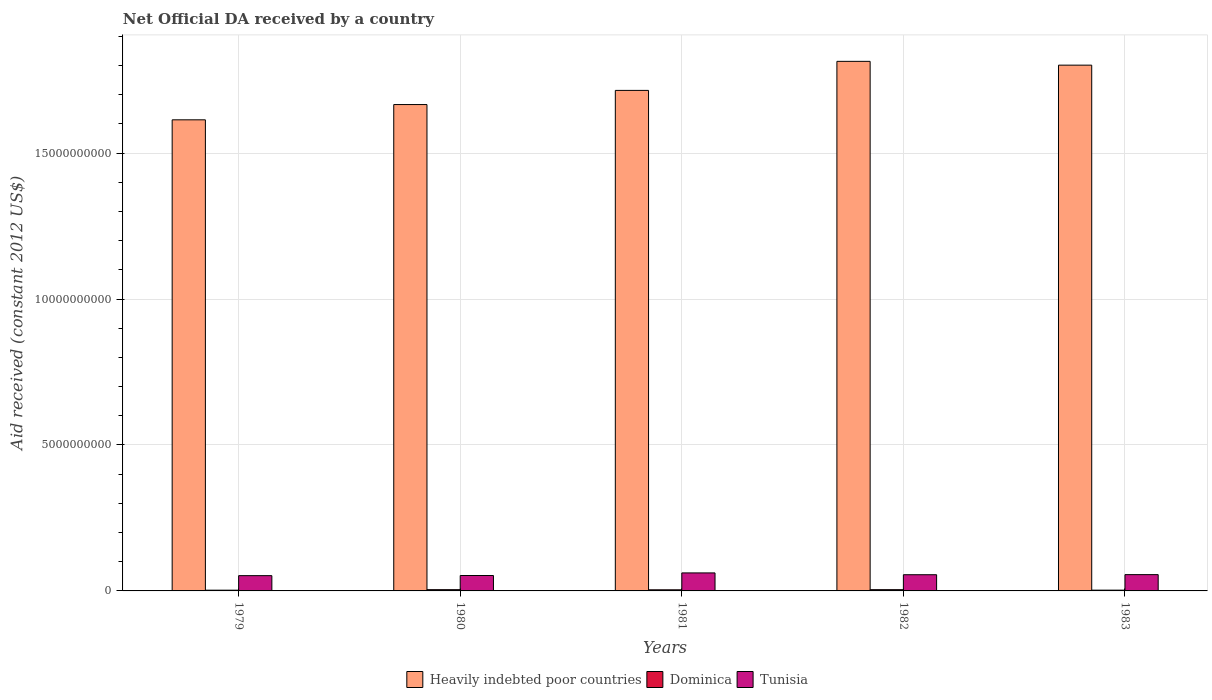How many groups of bars are there?
Offer a terse response. 5. Are the number of bars on each tick of the X-axis equal?
Provide a succinct answer. Yes. How many bars are there on the 5th tick from the right?
Ensure brevity in your answer.  3. What is the label of the 3rd group of bars from the left?
Your answer should be compact. 1981. What is the net official development assistance aid received in Heavily indebted poor countries in 1981?
Ensure brevity in your answer.  1.71e+1. Across all years, what is the maximum net official development assistance aid received in Tunisia?
Ensure brevity in your answer.  6.17e+08. Across all years, what is the minimum net official development assistance aid received in Dominica?
Ensure brevity in your answer.  2.53e+07. In which year was the net official development assistance aid received in Tunisia maximum?
Make the answer very short. 1981. In which year was the net official development assistance aid received in Heavily indebted poor countries minimum?
Ensure brevity in your answer.  1979. What is the total net official development assistance aid received in Heavily indebted poor countries in the graph?
Offer a very short reply. 8.61e+1. What is the difference between the net official development assistance aid received in Heavily indebted poor countries in 1980 and that in 1982?
Offer a terse response. -1.48e+09. What is the difference between the net official development assistance aid received in Dominica in 1981 and the net official development assistance aid received in Heavily indebted poor countries in 1980?
Offer a very short reply. -1.66e+1. What is the average net official development assistance aid received in Tunisia per year?
Your answer should be compact. 5.56e+08. In the year 1981, what is the difference between the net official development assistance aid received in Heavily indebted poor countries and net official development assistance aid received in Dominica?
Make the answer very short. 1.71e+1. What is the ratio of the net official development assistance aid received in Tunisia in 1980 to that in 1982?
Make the answer very short. 0.95. What is the difference between the highest and the second highest net official development assistance aid received in Dominica?
Make the answer very short. 1.50e+05. What is the difference between the highest and the lowest net official development assistance aid received in Heavily indebted poor countries?
Offer a very short reply. 2.00e+09. What does the 2nd bar from the left in 1982 represents?
Your response must be concise. Dominica. What does the 3rd bar from the right in 1980 represents?
Offer a terse response. Heavily indebted poor countries. Is it the case that in every year, the sum of the net official development assistance aid received in Dominica and net official development assistance aid received in Tunisia is greater than the net official development assistance aid received in Heavily indebted poor countries?
Give a very brief answer. No. How many bars are there?
Your answer should be compact. 15. Are all the bars in the graph horizontal?
Your answer should be very brief. No. How many years are there in the graph?
Ensure brevity in your answer.  5. Does the graph contain any zero values?
Offer a terse response. No. Does the graph contain grids?
Provide a short and direct response. Yes. Where does the legend appear in the graph?
Keep it short and to the point. Bottom center. How are the legend labels stacked?
Make the answer very short. Horizontal. What is the title of the graph?
Provide a succinct answer. Net Official DA received by a country. What is the label or title of the X-axis?
Keep it short and to the point. Years. What is the label or title of the Y-axis?
Provide a succinct answer. Aid received (constant 2012 US$). What is the Aid received (constant 2012 US$) of Heavily indebted poor countries in 1979?
Ensure brevity in your answer.  1.61e+1. What is the Aid received (constant 2012 US$) in Dominica in 1979?
Keep it short and to the point. 2.53e+07. What is the Aid received (constant 2012 US$) in Tunisia in 1979?
Provide a succinct answer. 5.23e+08. What is the Aid received (constant 2012 US$) of Heavily indebted poor countries in 1980?
Give a very brief answer. 1.67e+1. What is the Aid received (constant 2012 US$) in Dominica in 1980?
Make the answer very short. 4.30e+07. What is the Aid received (constant 2012 US$) in Tunisia in 1980?
Offer a terse response. 5.28e+08. What is the Aid received (constant 2012 US$) of Heavily indebted poor countries in 1981?
Offer a very short reply. 1.71e+1. What is the Aid received (constant 2012 US$) of Dominica in 1981?
Your answer should be very brief. 3.84e+07. What is the Aid received (constant 2012 US$) in Tunisia in 1981?
Your response must be concise. 6.17e+08. What is the Aid received (constant 2012 US$) in Heavily indebted poor countries in 1982?
Provide a succinct answer. 1.81e+1. What is the Aid received (constant 2012 US$) of Dominica in 1982?
Give a very brief answer. 4.32e+07. What is the Aid received (constant 2012 US$) of Tunisia in 1982?
Provide a short and direct response. 5.55e+08. What is the Aid received (constant 2012 US$) of Heavily indebted poor countries in 1983?
Provide a succinct answer. 1.80e+1. What is the Aid received (constant 2012 US$) in Dominica in 1983?
Keep it short and to the point. 2.66e+07. What is the Aid received (constant 2012 US$) of Tunisia in 1983?
Provide a short and direct response. 5.58e+08. Across all years, what is the maximum Aid received (constant 2012 US$) of Heavily indebted poor countries?
Offer a terse response. 1.81e+1. Across all years, what is the maximum Aid received (constant 2012 US$) of Dominica?
Keep it short and to the point. 4.32e+07. Across all years, what is the maximum Aid received (constant 2012 US$) in Tunisia?
Your response must be concise. 6.17e+08. Across all years, what is the minimum Aid received (constant 2012 US$) of Heavily indebted poor countries?
Make the answer very short. 1.61e+1. Across all years, what is the minimum Aid received (constant 2012 US$) of Dominica?
Keep it short and to the point. 2.53e+07. Across all years, what is the minimum Aid received (constant 2012 US$) of Tunisia?
Offer a very short reply. 5.23e+08. What is the total Aid received (constant 2012 US$) in Heavily indebted poor countries in the graph?
Your answer should be very brief. 8.61e+1. What is the total Aid received (constant 2012 US$) in Dominica in the graph?
Offer a very short reply. 1.77e+08. What is the total Aid received (constant 2012 US$) in Tunisia in the graph?
Give a very brief answer. 2.78e+09. What is the difference between the Aid received (constant 2012 US$) in Heavily indebted poor countries in 1979 and that in 1980?
Give a very brief answer. -5.23e+08. What is the difference between the Aid received (constant 2012 US$) of Dominica in 1979 and that in 1980?
Your answer should be very brief. -1.78e+07. What is the difference between the Aid received (constant 2012 US$) in Tunisia in 1979 and that in 1980?
Offer a very short reply. -4.92e+06. What is the difference between the Aid received (constant 2012 US$) in Heavily indebted poor countries in 1979 and that in 1981?
Offer a terse response. -1.01e+09. What is the difference between the Aid received (constant 2012 US$) of Dominica in 1979 and that in 1981?
Offer a very short reply. -1.32e+07. What is the difference between the Aid received (constant 2012 US$) in Tunisia in 1979 and that in 1981?
Your answer should be very brief. -9.37e+07. What is the difference between the Aid received (constant 2012 US$) in Heavily indebted poor countries in 1979 and that in 1982?
Provide a succinct answer. -2.00e+09. What is the difference between the Aid received (constant 2012 US$) of Dominica in 1979 and that in 1982?
Your answer should be very brief. -1.79e+07. What is the difference between the Aid received (constant 2012 US$) in Tunisia in 1979 and that in 1982?
Provide a short and direct response. -3.15e+07. What is the difference between the Aid received (constant 2012 US$) of Heavily indebted poor countries in 1979 and that in 1983?
Offer a very short reply. -1.87e+09. What is the difference between the Aid received (constant 2012 US$) in Dominica in 1979 and that in 1983?
Provide a succinct answer. -1.36e+06. What is the difference between the Aid received (constant 2012 US$) of Tunisia in 1979 and that in 1983?
Provide a succinct answer. -3.49e+07. What is the difference between the Aid received (constant 2012 US$) of Heavily indebted poor countries in 1980 and that in 1981?
Offer a very short reply. -4.85e+08. What is the difference between the Aid received (constant 2012 US$) of Dominica in 1980 and that in 1981?
Provide a short and direct response. 4.58e+06. What is the difference between the Aid received (constant 2012 US$) in Tunisia in 1980 and that in 1981?
Offer a very short reply. -8.88e+07. What is the difference between the Aid received (constant 2012 US$) in Heavily indebted poor countries in 1980 and that in 1982?
Make the answer very short. -1.48e+09. What is the difference between the Aid received (constant 2012 US$) in Tunisia in 1980 and that in 1982?
Make the answer very short. -2.66e+07. What is the difference between the Aid received (constant 2012 US$) of Heavily indebted poor countries in 1980 and that in 1983?
Ensure brevity in your answer.  -1.35e+09. What is the difference between the Aid received (constant 2012 US$) of Dominica in 1980 and that in 1983?
Ensure brevity in your answer.  1.64e+07. What is the difference between the Aid received (constant 2012 US$) in Tunisia in 1980 and that in 1983?
Offer a very short reply. -3.00e+07. What is the difference between the Aid received (constant 2012 US$) in Heavily indebted poor countries in 1981 and that in 1982?
Provide a short and direct response. -9.95e+08. What is the difference between the Aid received (constant 2012 US$) in Dominica in 1981 and that in 1982?
Offer a terse response. -4.73e+06. What is the difference between the Aid received (constant 2012 US$) of Tunisia in 1981 and that in 1982?
Ensure brevity in your answer.  6.22e+07. What is the difference between the Aid received (constant 2012 US$) of Heavily indebted poor countries in 1981 and that in 1983?
Provide a succinct answer. -8.65e+08. What is the difference between the Aid received (constant 2012 US$) of Dominica in 1981 and that in 1983?
Offer a terse response. 1.18e+07. What is the difference between the Aid received (constant 2012 US$) in Tunisia in 1981 and that in 1983?
Your response must be concise. 5.88e+07. What is the difference between the Aid received (constant 2012 US$) in Heavily indebted poor countries in 1982 and that in 1983?
Your response must be concise. 1.30e+08. What is the difference between the Aid received (constant 2012 US$) of Dominica in 1982 and that in 1983?
Your answer should be very brief. 1.66e+07. What is the difference between the Aid received (constant 2012 US$) in Tunisia in 1982 and that in 1983?
Offer a very short reply. -3.40e+06. What is the difference between the Aid received (constant 2012 US$) in Heavily indebted poor countries in 1979 and the Aid received (constant 2012 US$) in Dominica in 1980?
Your answer should be very brief. 1.61e+1. What is the difference between the Aid received (constant 2012 US$) in Heavily indebted poor countries in 1979 and the Aid received (constant 2012 US$) in Tunisia in 1980?
Make the answer very short. 1.56e+1. What is the difference between the Aid received (constant 2012 US$) of Dominica in 1979 and the Aid received (constant 2012 US$) of Tunisia in 1980?
Offer a terse response. -5.03e+08. What is the difference between the Aid received (constant 2012 US$) of Heavily indebted poor countries in 1979 and the Aid received (constant 2012 US$) of Dominica in 1981?
Your answer should be compact. 1.61e+1. What is the difference between the Aid received (constant 2012 US$) of Heavily indebted poor countries in 1979 and the Aid received (constant 2012 US$) of Tunisia in 1981?
Ensure brevity in your answer.  1.55e+1. What is the difference between the Aid received (constant 2012 US$) in Dominica in 1979 and the Aid received (constant 2012 US$) in Tunisia in 1981?
Make the answer very short. -5.92e+08. What is the difference between the Aid received (constant 2012 US$) of Heavily indebted poor countries in 1979 and the Aid received (constant 2012 US$) of Dominica in 1982?
Provide a succinct answer. 1.61e+1. What is the difference between the Aid received (constant 2012 US$) of Heavily indebted poor countries in 1979 and the Aid received (constant 2012 US$) of Tunisia in 1982?
Provide a succinct answer. 1.56e+1. What is the difference between the Aid received (constant 2012 US$) of Dominica in 1979 and the Aid received (constant 2012 US$) of Tunisia in 1982?
Keep it short and to the point. -5.30e+08. What is the difference between the Aid received (constant 2012 US$) in Heavily indebted poor countries in 1979 and the Aid received (constant 2012 US$) in Dominica in 1983?
Your answer should be compact. 1.61e+1. What is the difference between the Aid received (constant 2012 US$) in Heavily indebted poor countries in 1979 and the Aid received (constant 2012 US$) in Tunisia in 1983?
Keep it short and to the point. 1.56e+1. What is the difference between the Aid received (constant 2012 US$) of Dominica in 1979 and the Aid received (constant 2012 US$) of Tunisia in 1983?
Make the answer very short. -5.33e+08. What is the difference between the Aid received (constant 2012 US$) of Heavily indebted poor countries in 1980 and the Aid received (constant 2012 US$) of Dominica in 1981?
Provide a short and direct response. 1.66e+1. What is the difference between the Aid received (constant 2012 US$) of Heavily indebted poor countries in 1980 and the Aid received (constant 2012 US$) of Tunisia in 1981?
Your answer should be compact. 1.60e+1. What is the difference between the Aid received (constant 2012 US$) in Dominica in 1980 and the Aid received (constant 2012 US$) in Tunisia in 1981?
Make the answer very short. -5.74e+08. What is the difference between the Aid received (constant 2012 US$) of Heavily indebted poor countries in 1980 and the Aid received (constant 2012 US$) of Dominica in 1982?
Give a very brief answer. 1.66e+1. What is the difference between the Aid received (constant 2012 US$) of Heavily indebted poor countries in 1980 and the Aid received (constant 2012 US$) of Tunisia in 1982?
Provide a short and direct response. 1.61e+1. What is the difference between the Aid received (constant 2012 US$) in Dominica in 1980 and the Aid received (constant 2012 US$) in Tunisia in 1982?
Your answer should be very brief. -5.12e+08. What is the difference between the Aid received (constant 2012 US$) in Heavily indebted poor countries in 1980 and the Aid received (constant 2012 US$) in Dominica in 1983?
Your answer should be very brief. 1.66e+1. What is the difference between the Aid received (constant 2012 US$) in Heavily indebted poor countries in 1980 and the Aid received (constant 2012 US$) in Tunisia in 1983?
Give a very brief answer. 1.61e+1. What is the difference between the Aid received (constant 2012 US$) of Dominica in 1980 and the Aid received (constant 2012 US$) of Tunisia in 1983?
Provide a short and direct response. -5.15e+08. What is the difference between the Aid received (constant 2012 US$) in Heavily indebted poor countries in 1981 and the Aid received (constant 2012 US$) in Dominica in 1982?
Give a very brief answer. 1.71e+1. What is the difference between the Aid received (constant 2012 US$) in Heavily indebted poor countries in 1981 and the Aid received (constant 2012 US$) in Tunisia in 1982?
Give a very brief answer. 1.66e+1. What is the difference between the Aid received (constant 2012 US$) of Dominica in 1981 and the Aid received (constant 2012 US$) of Tunisia in 1982?
Provide a succinct answer. -5.16e+08. What is the difference between the Aid received (constant 2012 US$) in Heavily indebted poor countries in 1981 and the Aid received (constant 2012 US$) in Dominica in 1983?
Offer a terse response. 1.71e+1. What is the difference between the Aid received (constant 2012 US$) of Heavily indebted poor countries in 1981 and the Aid received (constant 2012 US$) of Tunisia in 1983?
Keep it short and to the point. 1.66e+1. What is the difference between the Aid received (constant 2012 US$) of Dominica in 1981 and the Aid received (constant 2012 US$) of Tunisia in 1983?
Offer a very short reply. -5.20e+08. What is the difference between the Aid received (constant 2012 US$) in Heavily indebted poor countries in 1982 and the Aid received (constant 2012 US$) in Dominica in 1983?
Keep it short and to the point. 1.81e+1. What is the difference between the Aid received (constant 2012 US$) in Heavily indebted poor countries in 1982 and the Aid received (constant 2012 US$) in Tunisia in 1983?
Give a very brief answer. 1.76e+1. What is the difference between the Aid received (constant 2012 US$) in Dominica in 1982 and the Aid received (constant 2012 US$) in Tunisia in 1983?
Keep it short and to the point. -5.15e+08. What is the average Aid received (constant 2012 US$) of Heavily indebted poor countries per year?
Offer a terse response. 1.72e+1. What is the average Aid received (constant 2012 US$) of Dominica per year?
Make the answer very short. 3.53e+07. What is the average Aid received (constant 2012 US$) of Tunisia per year?
Your answer should be very brief. 5.56e+08. In the year 1979, what is the difference between the Aid received (constant 2012 US$) of Heavily indebted poor countries and Aid received (constant 2012 US$) of Dominica?
Provide a succinct answer. 1.61e+1. In the year 1979, what is the difference between the Aid received (constant 2012 US$) of Heavily indebted poor countries and Aid received (constant 2012 US$) of Tunisia?
Keep it short and to the point. 1.56e+1. In the year 1979, what is the difference between the Aid received (constant 2012 US$) of Dominica and Aid received (constant 2012 US$) of Tunisia?
Your answer should be compact. -4.98e+08. In the year 1980, what is the difference between the Aid received (constant 2012 US$) in Heavily indebted poor countries and Aid received (constant 2012 US$) in Dominica?
Provide a succinct answer. 1.66e+1. In the year 1980, what is the difference between the Aid received (constant 2012 US$) of Heavily indebted poor countries and Aid received (constant 2012 US$) of Tunisia?
Your answer should be compact. 1.61e+1. In the year 1980, what is the difference between the Aid received (constant 2012 US$) in Dominica and Aid received (constant 2012 US$) in Tunisia?
Ensure brevity in your answer.  -4.85e+08. In the year 1981, what is the difference between the Aid received (constant 2012 US$) of Heavily indebted poor countries and Aid received (constant 2012 US$) of Dominica?
Give a very brief answer. 1.71e+1. In the year 1981, what is the difference between the Aid received (constant 2012 US$) in Heavily indebted poor countries and Aid received (constant 2012 US$) in Tunisia?
Give a very brief answer. 1.65e+1. In the year 1981, what is the difference between the Aid received (constant 2012 US$) in Dominica and Aid received (constant 2012 US$) in Tunisia?
Ensure brevity in your answer.  -5.79e+08. In the year 1982, what is the difference between the Aid received (constant 2012 US$) in Heavily indebted poor countries and Aid received (constant 2012 US$) in Dominica?
Provide a succinct answer. 1.81e+1. In the year 1982, what is the difference between the Aid received (constant 2012 US$) of Heavily indebted poor countries and Aid received (constant 2012 US$) of Tunisia?
Give a very brief answer. 1.76e+1. In the year 1982, what is the difference between the Aid received (constant 2012 US$) of Dominica and Aid received (constant 2012 US$) of Tunisia?
Provide a succinct answer. -5.12e+08. In the year 1983, what is the difference between the Aid received (constant 2012 US$) of Heavily indebted poor countries and Aid received (constant 2012 US$) of Dominica?
Your response must be concise. 1.80e+1. In the year 1983, what is the difference between the Aid received (constant 2012 US$) of Heavily indebted poor countries and Aid received (constant 2012 US$) of Tunisia?
Keep it short and to the point. 1.75e+1. In the year 1983, what is the difference between the Aid received (constant 2012 US$) of Dominica and Aid received (constant 2012 US$) of Tunisia?
Make the answer very short. -5.32e+08. What is the ratio of the Aid received (constant 2012 US$) of Heavily indebted poor countries in 1979 to that in 1980?
Provide a succinct answer. 0.97. What is the ratio of the Aid received (constant 2012 US$) of Dominica in 1979 to that in 1980?
Offer a very short reply. 0.59. What is the ratio of the Aid received (constant 2012 US$) of Tunisia in 1979 to that in 1980?
Keep it short and to the point. 0.99. What is the ratio of the Aid received (constant 2012 US$) in Dominica in 1979 to that in 1981?
Offer a very short reply. 0.66. What is the ratio of the Aid received (constant 2012 US$) of Tunisia in 1979 to that in 1981?
Ensure brevity in your answer.  0.85. What is the ratio of the Aid received (constant 2012 US$) in Heavily indebted poor countries in 1979 to that in 1982?
Your response must be concise. 0.89. What is the ratio of the Aid received (constant 2012 US$) of Dominica in 1979 to that in 1982?
Your answer should be very brief. 0.59. What is the ratio of the Aid received (constant 2012 US$) of Tunisia in 1979 to that in 1982?
Provide a short and direct response. 0.94. What is the ratio of the Aid received (constant 2012 US$) in Heavily indebted poor countries in 1979 to that in 1983?
Provide a short and direct response. 0.9. What is the ratio of the Aid received (constant 2012 US$) of Dominica in 1979 to that in 1983?
Make the answer very short. 0.95. What is the ratio of the Aid received (constant 2012 US$) in Tunisia in 1979 to that in 1983?
Your answer should be compact. 0.94. What is the ratio of the Aid received (constant 2012 US$) in Heavily indebted poor countries in 1980 to that in 1981?
Provide a short and direct response. 0.97. What is the ratio of the Aid received (constant 2012 US$) of Dominica in 1980 to that in 1981?
Provide a short and direct response. 1.12. What is the ratio of the Aid received (constant 2012 US$) of Tunisia in 1980 to that in 1981?
Offer a terse response. 0.86. What is the ratio of the Aid received (constant 2012 US$) of Heavily indebted poor countries in 1980 to that in 1982?
Make the answer very short. 0.92. What is the ratio of the Aid received (constant 2012 US$) of Heavily indebted poor countries in 1980 to that in 1983?
Give a very brief answer. 0.93. What is the ratio of the Aid received (constant 2012 US$) in Dominica in 1980 to that in 1983?
Your answer should be compact. 1.62. What is the ratio of the Aid received (constant 2012 US$) in Tunisia in 1980 to that in 1983?
Keep it short and to the point. 0.95. What is the ratio of the Aid received (constant 2012 US$) of Heavily indebted poor countries in 1981 to that in 1982?
Offer a very short reply. 0.95. What is the ratio of the Aid received (constant 2012 US$) in Dominica in 1981 to that in 1982?
Offer a very short reply. 0.89. What is the ratio of the Aid received (constant 2012 US$) in Tunisia in 1981 to that in 1982?
Ensure brevity in your answer.  1.11. What is the ratio of the Aid received (constant 2012 US$) of Dominica in 1981 to that in 1983?
Offer a terse response. 1.44. What is the ratio of the Aid received (constant 2012 US$) in Tunisia in 1981 to that in 1983?
Provide a short and direct response. 1.11. What is the ratio of the Aid received (constant 2012 US$) of Heavily indebted poor countries in 1982 to that in 1983?
Your answer should be compact. 1.01. What is the ratio of the Aid received (constant 2012 US$) in Dominica in 1982 to that in 1983?
Offer a terse response. 1.62. What is the difference between the highest and the second highest Aid received (constant 2012 US$) of Heavily indebted poor countries?
Your answer should be very brief. 1.30e+08. What is the difference between the highest and the second highest Aid received (constant 2012 US$) in Dominica?
Your response must be concise. 1.50e+05. What is the difference between the highest and the second highest Aid received (constant 2012 US$) of Tunisia?
Give a very brief answer. 5.88e+07. What is the difference between the highest and the lowest Aid received (constant 2012 US$) of Heavily indebted poor countries?
Ensure brevity in your answer.  2.00e+09. What is the difference between the highest and the lowest Aid received (constant 2012 US$) of Dominica?
Give a very brief answer. 1.79e+07. What is the difference between the highest and the lowest Aid received (constant 2012 US$) in Tunisia?
Provide a succinct answer. 9.37e+07. 